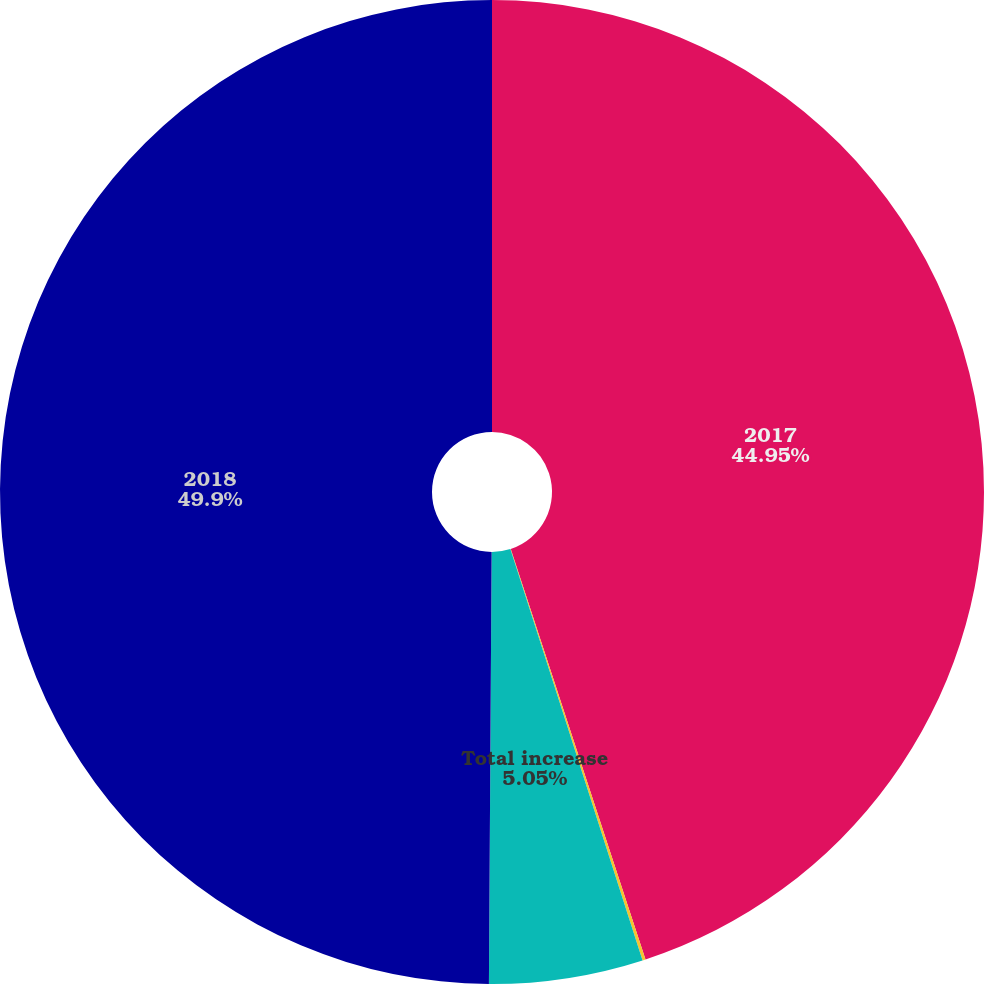Convert chart to OTSL. <chart><loc_0><loc_0><loc_500><loc_500><pie_chart><fcel>2017<fcel>Currency translation and other<fcel>Total increase<fcel>2018<nl><fcel>44.95%<fcel>0.1%<fcel>5.05%<fcel>49.9%<nl></chart> 